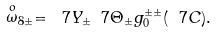Convert formula to latex. <formula><loc_0><loc_0><loc_500><loc_500>\stackrel { o } { \omega } _ { 8 \pm } = \ 7 Y _ { \pm } \ 7 \Theta _ { \pm } g _ { 0 } ^ { \pm \pm } ( \ 7 C ) .</formula> 